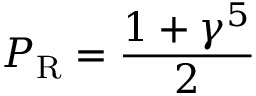Convert formula to latex. <formula><loc_0><loc_0><loc_500><loc_500>P _ { R } = { \frac { 1 + \gamma ^ { 5 } } { 2 } }</formula> 